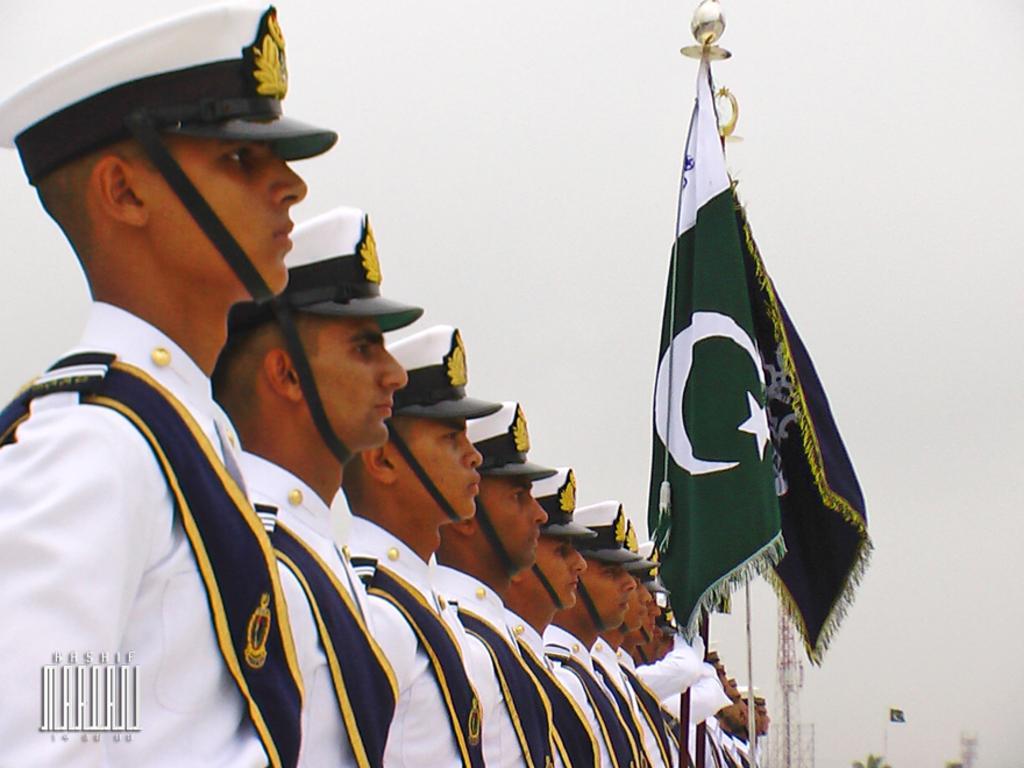How would you summarize this image in a sentence or two? In this image I can see few people are standing and wearing uniform. I can see flags and tower. The sky is in white color. 